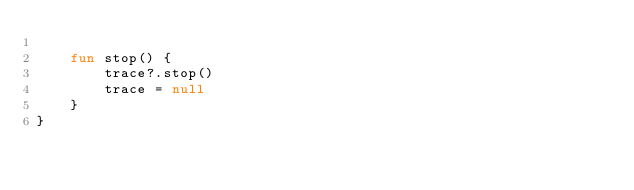Convert code to text. <code><loc_0><loc_0><loc_500><loc_500><_Kotlin_>
    fun stop() {
        trace?.stop()
        trace = null
    }
}
</code> 